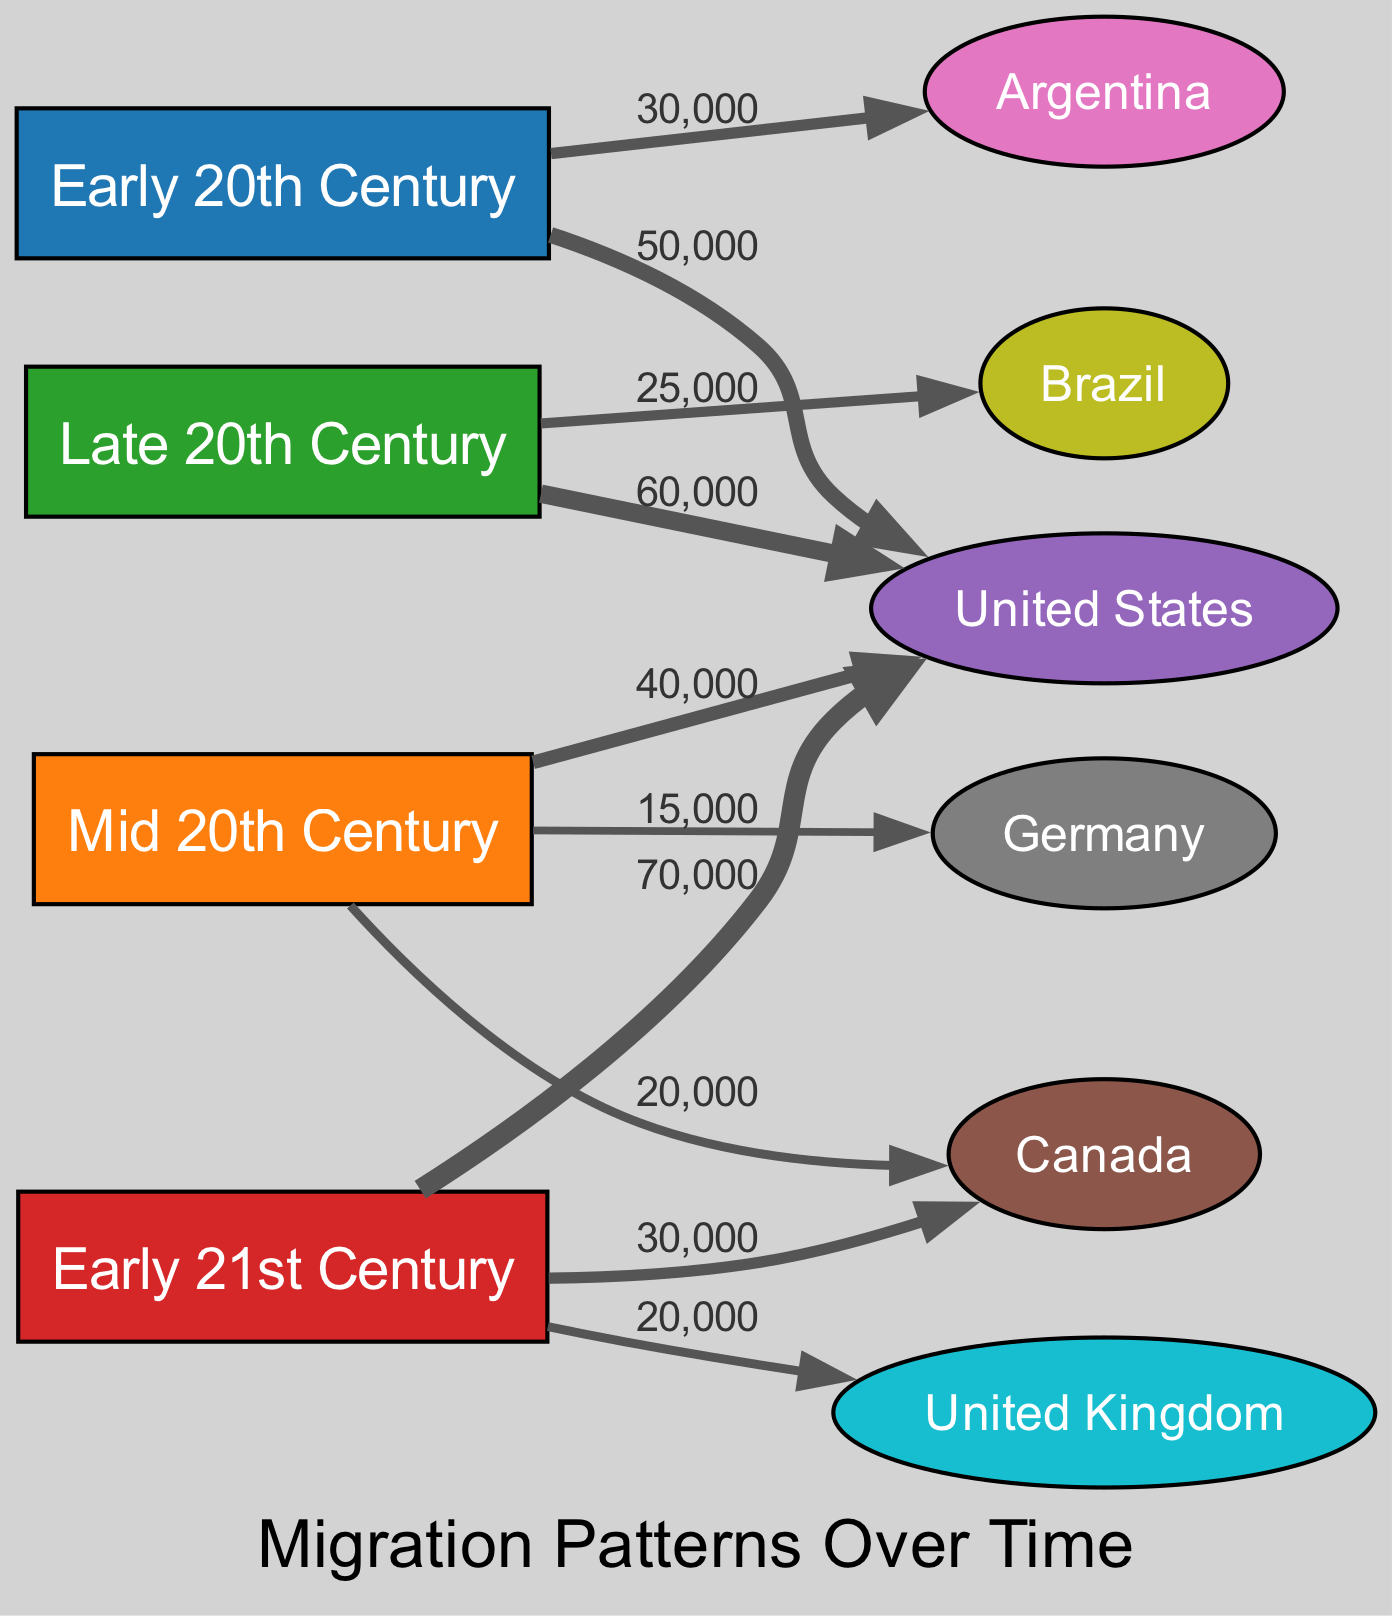What was the destination with the highest migration in the Early 21st Century? The Early 21st Century node connects to the United States with a value of 70,000, which is higher than any other destination in that period.
Answer: United States How many people migrated to Canada in the Mid 20th Century? The link from the Mid 20th Century node to Canada shows a value of 20,000, indicating that this was the number of migrants during that period.
Answer: 20,000 Which period saw the largest migration to the United States? By comparing the migration values to the United States across different time periods—50,000 in the Early 20th Century, 40,000 in the Mid 20th Century, 60,000 in the Late 20th Century, and 70,000 in the Early 21st Century—it’s clear that the Early 21st Century had the largest migration.
Answer: Early 21st Century What is the total migration to Argentine across all periods? The values linked to Argentina are 30,000 from the Early 20th Century and none from the later periods. Thus, the total population that migrated to Argentina is simply 30,000.
Answer: 30,000 How many total migration paths are there in the diagram? The count of links connecting nodes represents migration paths. There are 10 unique links showing migration flows, thus indicating the total number of migration paths in the diagram.
Answer: 10 From which period did migration to Germany begin, and what was the value? In the Mid 20th Century, the link to Germany shows a value of 15,000, indicating this was the first recorded migration to Germany in the provided data.
Answer: Mid 20th Century, 15,000 Which destination country had the lowest migration value in the Late 20th Century? The Late 20th Century node has only one link to Brazil with a value of 25,000 and no other destinations listed. Therefore, Brazil had the lowest migration value during this period.
Answer: Brazil Which two periods had the same migration value to the United States? In the analysis of links to the United States, the values from the Mid 20th Century (40,000) and Late 20th Century (60,000) differ from each other, however, two periods linked to show similar trends are the Early 20th Century and Mid 20th Century—both moving in an upward flow over time.
Answer: No periods have the same value 